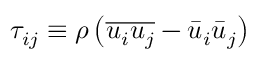<formula> <loc_0><loc_0><loc_500><loc_500>\tau _ { i j } \equiv \rho \left ( \overline { { u _ { i } u _ { j } } } - \bar { u } _ { i } \bar { u } _ { j } \right )</formula> 